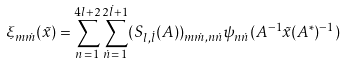Convert formula to latex. <formula><loc_0><loc_0><loc_500><loc_500>\xi _ { m \dot { m } } ( \tilde { x } ) = \sum _ { n \, = \, 1 } ^ { 4 l + 2 } \sum _ { \dot { n } \, = \, 1 } ^ { 2 \dot { l } + 1 } ( S _ { l , \dot { l } } ( A ) ) _ { m \dot { m } , n \dot { n } } \psi _ { n \dot { n } } ( A ^ { - 1 } \tilde { x } ( A ^ { \ast } ) ^ { - 1 } )</formula> 